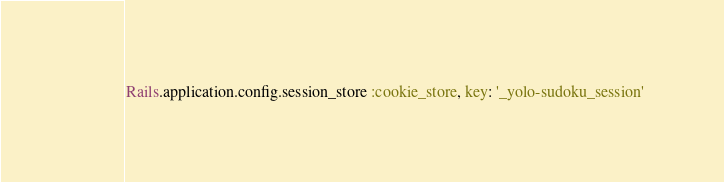<code> <loc_0><loc_0><loc_500><loc_500><_Ruby_>Rails.application.config.session_store :cookie_store, key: '_yolo-sudoku_session'
</code> 